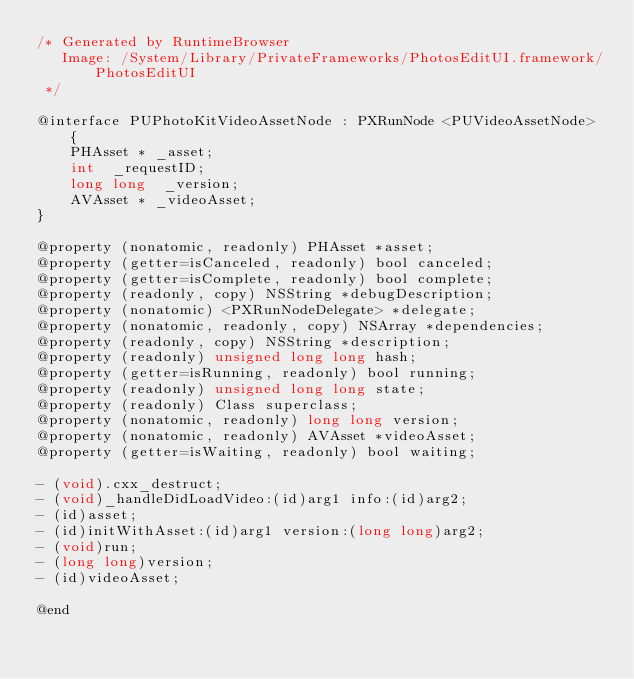Convert code to text. <code><loc_0><loc_0><loc_500><loc_500><_C_>/* Generated by RuntimeBrowser
   Image: /System/Library/PrivateFrameworks/PhotosEditUI.framework/PhotosEditUI
 */

@interface PUPhotoKitVideoAssetNode : PXRunNode <PUVideoAssetNode> {
    PHAsset * _asset;
    int  _requestID;
    long long  _version;
    AVAsset * _videoAsset;
}

@property (nonatomic, readonly) PHAsset *asset;
@property (getter=isCanceled, readonly) bool canceled;
@property (getter=isComplete, readonly) bool complete;
@property (readonly, copy) NSString *debugDescription;
@property (nonatomic) <PXRunNodeDelegate> *delegate;
@property (nonatomic, readonly, copy) NSArray *dependencies;
@property (readonly, copy) NSString *description;
@property (readonly) unsigned long long hash;
@property (getter=isRunning, readonly) bool running;
@property (readonly) unsigned long long state;
@property (readonly) Class superclass;
@property (nonatomic, readonly) long long version;
@property (nonatomic, readonly) AVAsset *videoAsset;
@property (getter=isWaiting, readonly) bool waiting;

- (void).cxx_destruct;
- (void)_handleDidLoadVideo:(id)arg1 info:(id)arg2;
- (id)asset;
- (id)initWithAsset:(id)arg1 version:(long long)arg2;
- (void)run;
- (long long)version;
- (id)videoAsset;

@end
</code> 